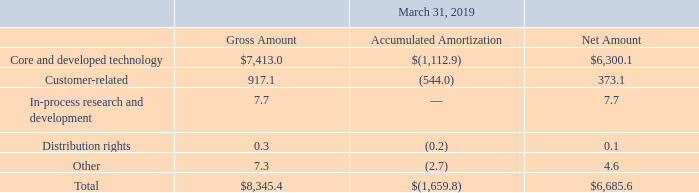Note 10. Intangible Assets and Goodwill
Intangible assets consist of the following (in millions):
What was the net amount of Customer-related assets?
Answer scale should be: million. 373.1. What was the gross amount of Core and developed technology assets?
Answer scale should be: million. 7,413.0. What was the Accumulated Amortization of Other assets?
Answer scale should be: million. (2.7). What was the difference between the gross amount of Distribution rights and Other assets?
Answer scale should be: million. 7.3-0.3
Answer: 7. What was the difference between the net amount of Customer-related assets and In-process research and development assets?
Answer scale should be: million. 373.1-7.7
Answer: 365.4. What was the net amount of Core and developed technology assets as a percentage of total intangible assets?
Answer scale should be: percent. 6,300.1/6,685.6
Answer: 94.23. 